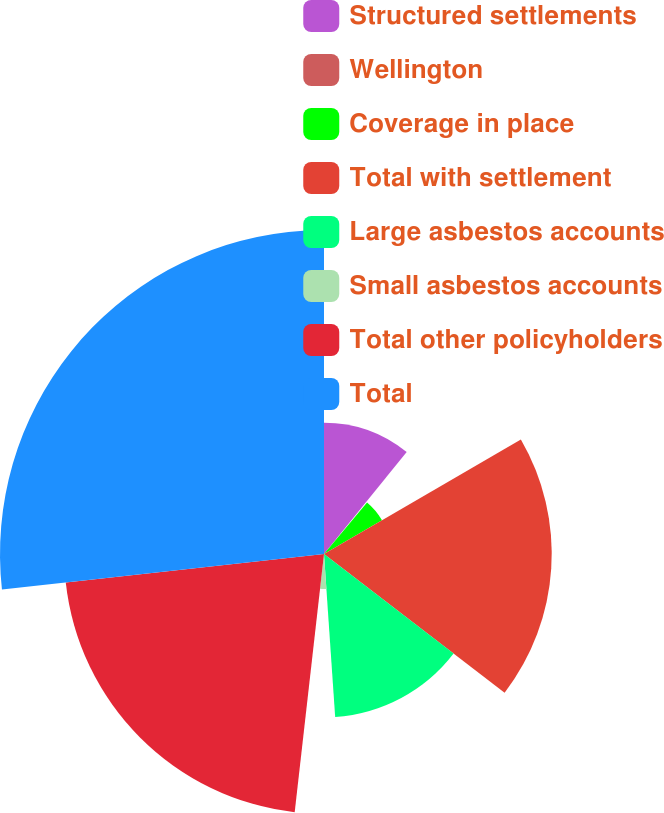<chart> <loc_0><loc_0><loc_500><loc_500><pie_chart><fcel>Structured settlements<fcel>Wellington<fcel>Coverage in place<fcel>Total with settlement<fcel>Large asbestos accounts<fcel>Small asbestos accounts<fcel>Total other policyholders<fcel>Total<nl><fcel>10.84%<fcel>0.24%<fcel>5.54%<fcel>18.8%<fcel>13.49%<fcel>2.89%<fcel>21.45%<fcel>26.75%<nl></chart> 